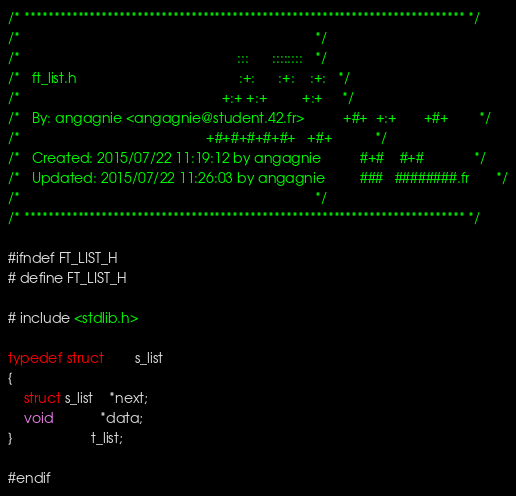<code> <loc_0><loc_0><loc_500><loc_500><_C_>/* ************************************************************************** */
/*                                                                            */
/*                                                        :::      ::::::::   */
/*   ft_list.h                                          :+:      :+:    :+:   */
/*                                                    +:+ +:+         +:+     */
/*   By: angagnie <angagnie@student.42.fr>          +#+  +:+       +#+        */
/*                                                +#+#+#+#+#+   +#+           */
/*   Created: 2015/07/22 11:19:12 by angagnie          #+#    #+#             */
/*   Updated: 2015/07/22 11:26:03 by angagnie         ###   ########.fr       */
/*                                                                            */
/* ************************************************************************** */

#ifndef FT_LIST_H
# define FT_LIST_H

# include <stdlib.h>

typedef struct		s_list
{
	struct s_list	*next;
	void			*data;
}					t_list;

#endif
</code> 